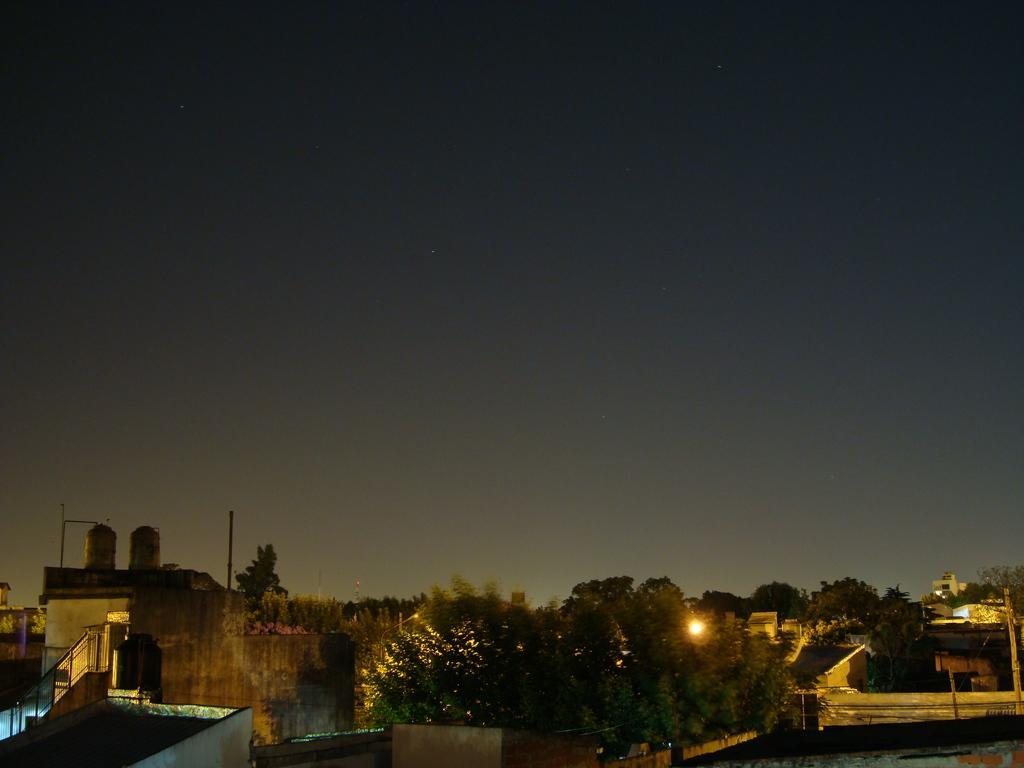What type of natural elements can be seen in the image? There are trees in the image. What type of man-made structures are present in the image? There are buildings in the image. What type of equipment can be seen in the image? There are water tanks in the image. What type of vertical structures are present in the image? There are poles in the image. What type of illumination sources are present in the image? There are lights in the image. What type of unspecified objects can be seen in the image? There are some objects in the image. What can be seen in the background of the image? The sky is visible in the background of the image. What position do the men hold in the image? There are no men present in the image. What type of things are being positioned by the men in the image? There are no men or things being positioned in the image. 